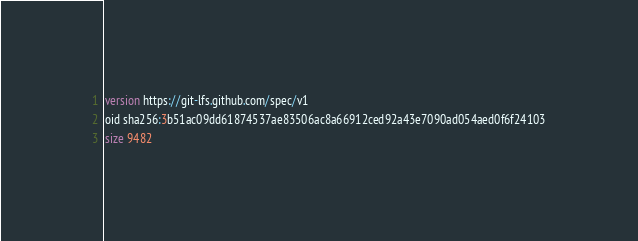Convert code to text. <code><loc_0><loc_0><loc_500><loc_500><_SQL_>version https://git-lfs.github.com/spec/v1
oid sha256:3b51ac09dd61874537ae83506ac8a66912ced92a43e7090ad054aed0f6f24103
size 9482
</code> 